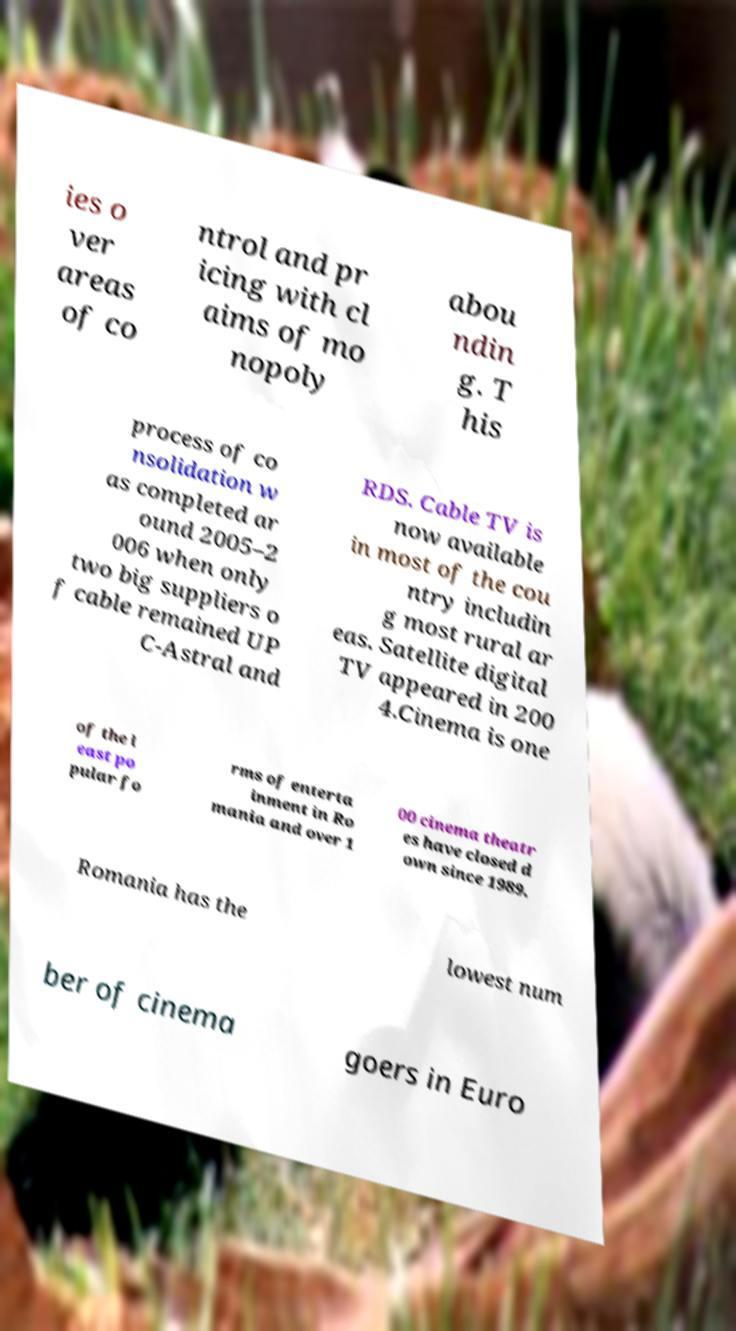Please read and relay the text visible in this image. What does it say? ies o ver areas of co ntrol and pr icing with cl aims of mo nopoly abou ndin g. T his process of co nsolidation w as completed ar ound 2005–2 006 when only two big suppliers o f cable remained UP C-Astral and RDS. Cable TV is now available in most of the cou ntry includin g most rural ar eas. Satellite digital TV appeared in 200 4.Cinema is one of the l east po pular fo rms of enterta inment in Ro mania and over 1 00 cinema theatr es have closed d own since 1989. Romania has the lowest num ber of cinema goers in Euro 